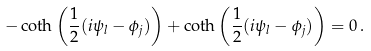Convert formula to latex. <formula><loc_0><loc_0><loc_500><loc_500>- \coth \left ( { \frac { 1 } { 2 } } ( i \psi _ { l } - \phi _ { j } ) \right ) + \coth \left ( { \frac { 1 } { 2 } } ( i \psi _ { l } - \phi _ { j } ) \right ) = 0 \, .</formula> 